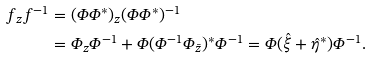<formula> <loc_0><loc_0><loc_500><loc_500>f _ { z } f ^ { - 1 } & = ( \varPhi \varPhi ^ { * } ) _ { z } ( \varPhi \varPhi ^ { * } ) ^ { - 1 } \\ & = \varPhi _ { z } \varPhi ^ { - 1 } + \varPhi ( \varPhi ^ { - 1 } \varPhi _ { \bar { z } } ) ^ { * } \varPhi ^ { - 1 } = \varPhi ( \hat { \xi } + \hat { \eta } ^ { * } ) \varPhi ^ { - 1 } .</formula> 